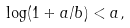Convert formula to latex. <formula><loc_0><loc_0><loc_500><loc_500>\log ( 1 + a / b ) < a ,</formula> 